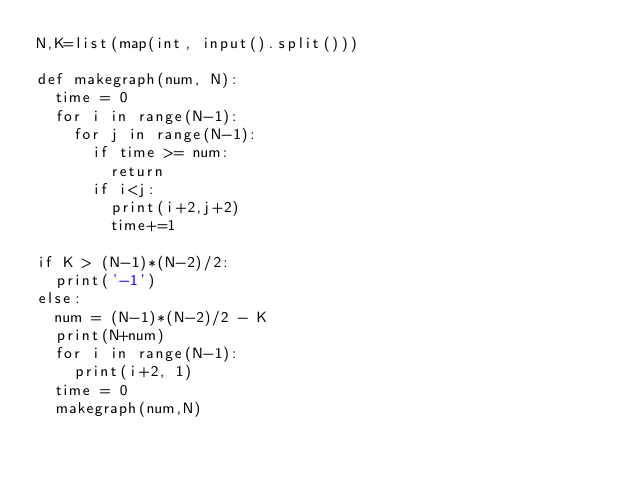<code> <loc_0><loc_0><loc_500><loc_500><_Python_>N,K=list(map(int, input().split()))

def makegraph(num, N): 
  time = 0
  for i in range(N-1):
    for j in range(N-1):
      if time >= num:
        return
      if i<j:
        print(i+2,j+2)
        time+=1

if K > (N-1)*(N-2)/2:
  print('-1')
else:
  num = (N-1)*(N-2)/2 - K
  print(N+num)
  for i in range(N-1):
    print(i+2, 1)
  time = 0        
  makegraph(num,N)
  


</code> 